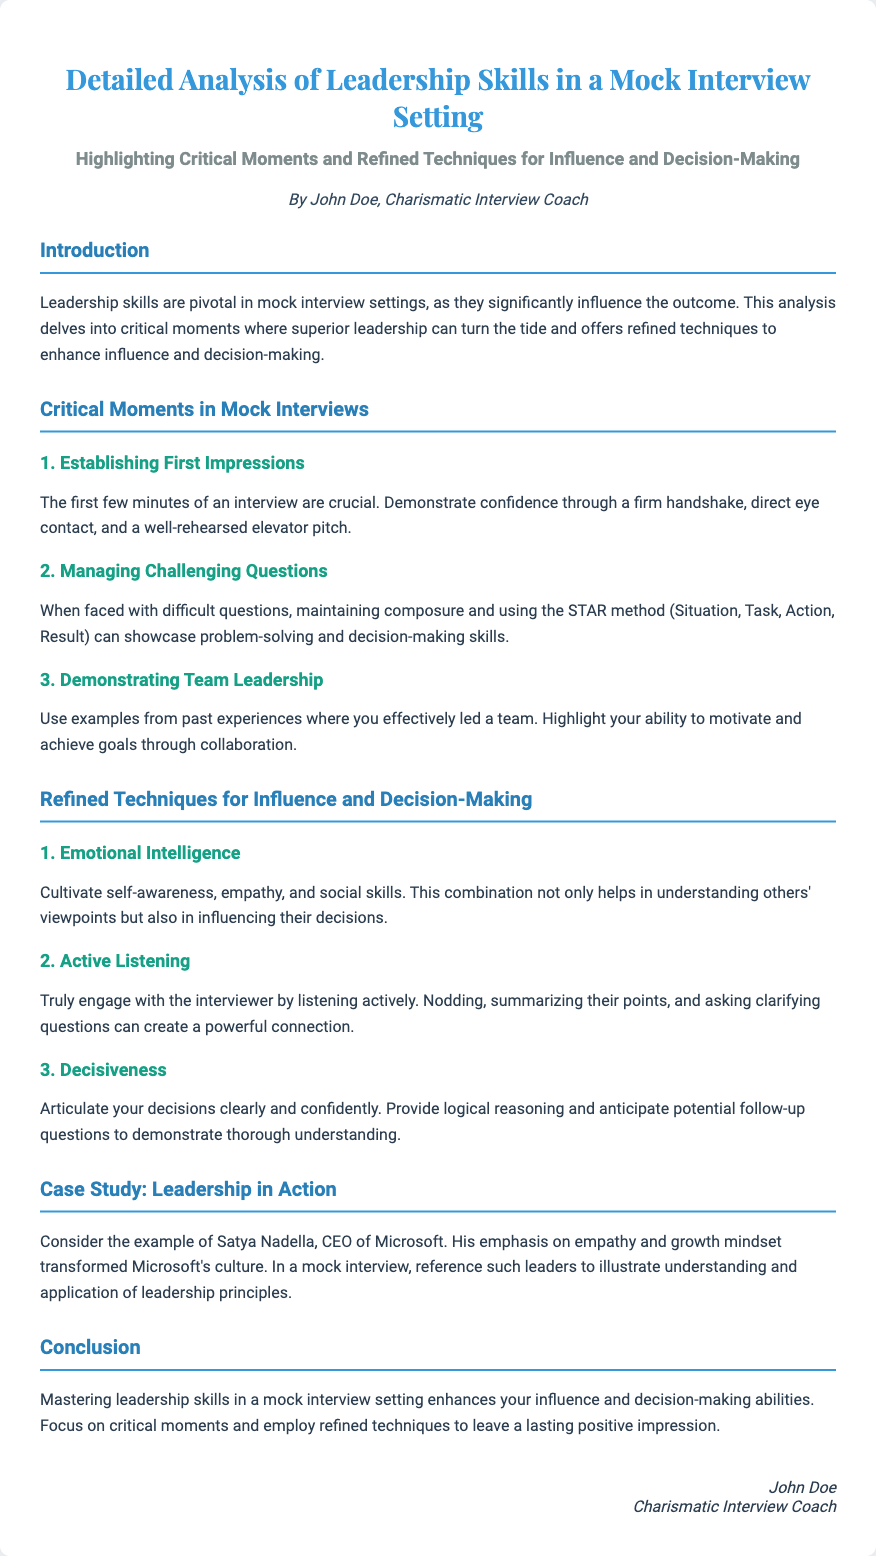What is the title of the diploma? The title of the diploma is provided in the header section, which specifies the focus of the analysis.
Answer: Detailed Analysis of Leadership Skills in a Mock Interview Setting Who is the author of the document? The author's name is mentioned in the author section of the diploma.
Answer: John Doe What are the three critical moments highlighted in the document? The critical moments mentioned are detailed in the section on Critical Moments in Mock Interviews.
Answer: Establishing First Impressions, Managing Challenging Questions, Demonstrating Team Leadership What method is suggested for managing challenging questions? The suggested method is specified for addressing difficult questions in interviews.
Answer: STAR method Which leadership quality is emphasized for influencing others? The document highlights a specific quality that helps in influencing decisions and is mentioned in the refined techniques section.
Answer: Emotional Intelligence What example is provided in the case study section? The case study section mentions a specific individual whose leadership is used as an example.
Answer: Satya Nadella What is the main conclusion drawn in the document? The conclusion summarizes the key takeaway regarding leadership skills in interviews.
Answer: Enhancing your influence and decision-making abilities How is active listening characterized in the document? Active listening is described in the section about refined techniques for influence and decision-making.
Answer: Engaging with the interviewer What is the background color of the diploma? The background color is specified in the CSS section of the document to give a visual context.
Answer: #f0f4f8 